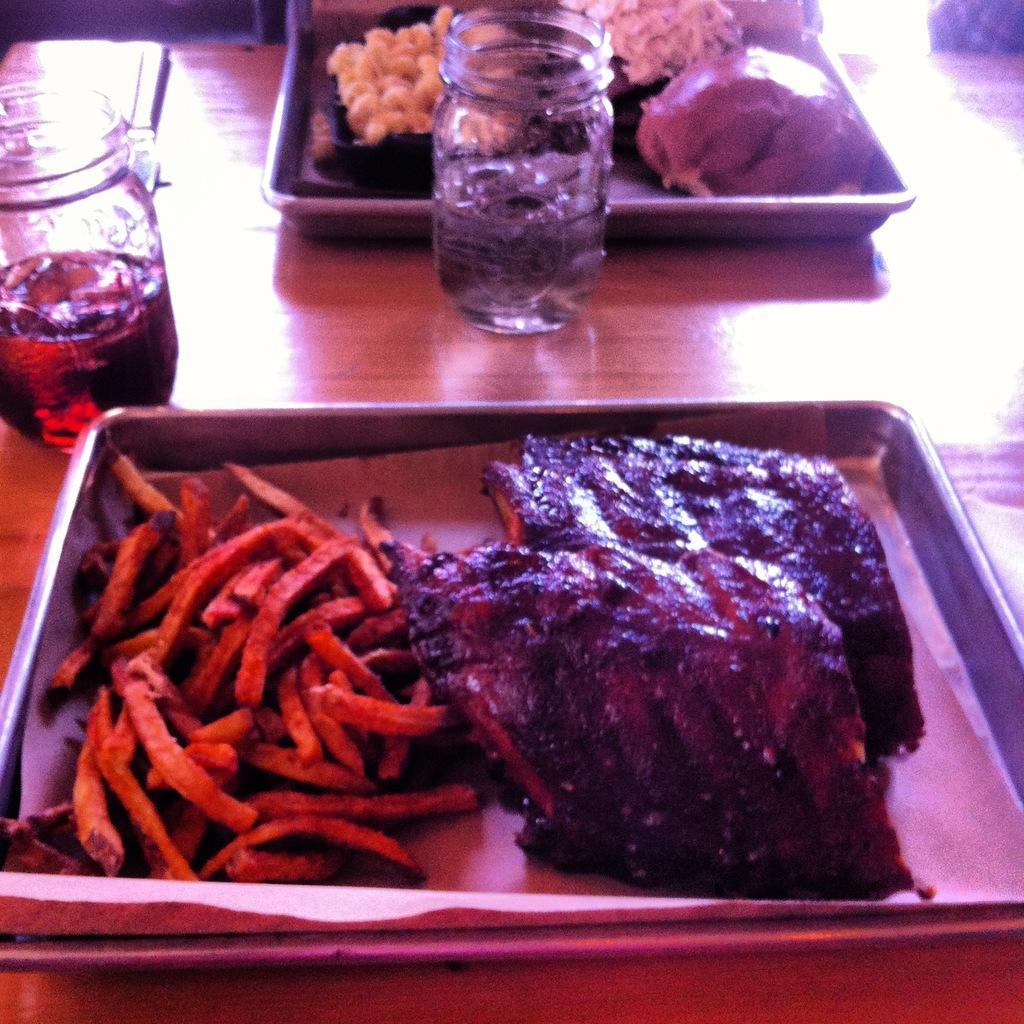Could you give a brief overview of what you see in this image? In the foreground of this picture we can see a table on the top of which glass jars containing liquids and the platters containing food items are placed. In the background we can see some objects. 